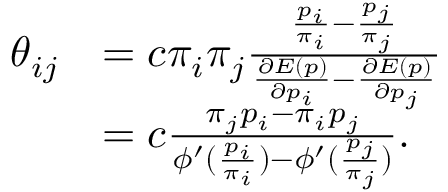<formula> <loc_0><loc_0><loc_500><loc_500>\begin{array} { r l } { \theta _ { i j } } & { = c \pi _ { i } \pi _ { j } \frac { \frac { p _ { i } } { \pi _ { i } } - \frac { p _ { j } } { \pi _ { j } } } { \frac { \partial E ( p ) } { \partial p _ { i } } - \frac { \partial E ( p ) } { \partial p _ { j } } } } \\ & { = c \frac { \pi _ { j } p _ { i } - \pi _ { i } p _ { j } } { \phi ^ { \prime } ( \frac { p _ { i } } { \pi _ { i } } ) - \phi ^ { \prime } ( \frac { p _ { j } } { \pi _ { j } } ) } . } \end{array}</formula> 